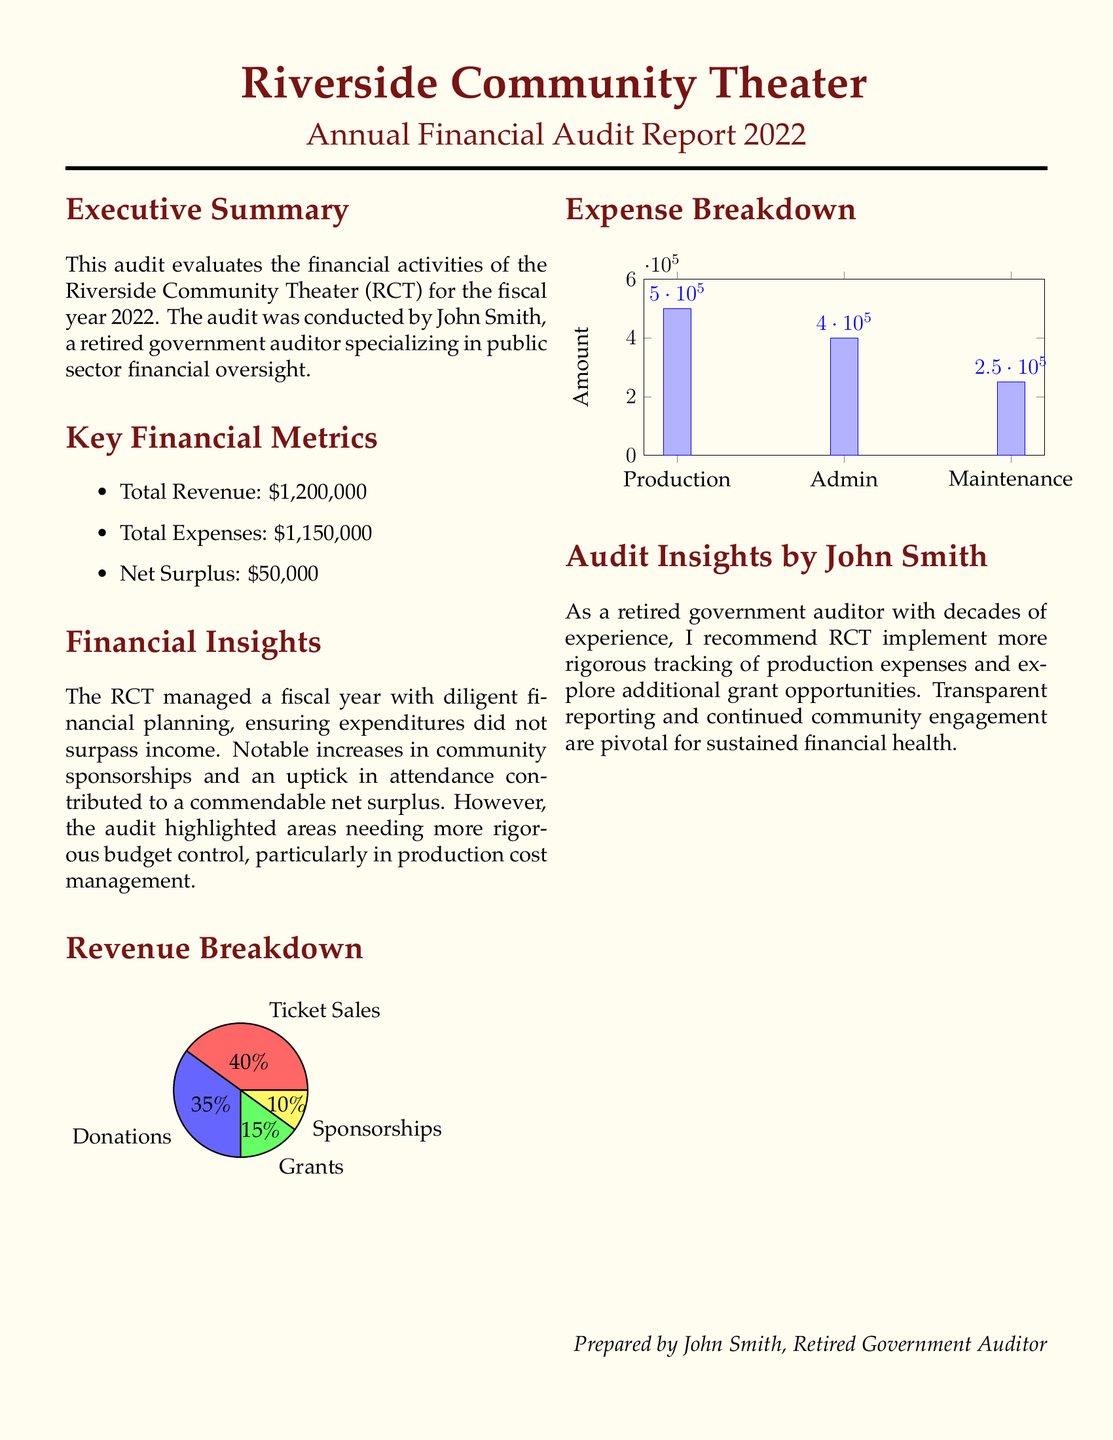What is the total revenue? The total revenue is stated in the document as $1,200,000.
Answer: $1,200,000 What is the net surplus for the year? The net surplus is calculated as total revenue minus total expenses, which is $50,000.
Answer: $50,000 Who conducted the audit? The audit was conducted by John Smith, mentioned in the executive summary.
Answer: John Smith What percentage of revenue came from ticket sales? The pie chart indicates that 40% of revenue was derived from ticket sales.
Answer: 40% What was the total expense amount? The total expenses reported in the document are $1,150,000.
Answer: $1,150,000 Which category had the highest expense? According to the expense breakdown, the category with the highest expense is Production.
Answer: Production What was the total amount allocated for maintenance? The expense breakdown specifies that the amount for maintenance is $250,000.
Answer: $250,000 What recommendation does John Smith provide regarding expenses? John Smith recommends implementing more rigorous tracking of production expenses.
Answer: Tracking production expenses What is the primary source of revenue after ticket sales? The primary source of revenue after ticket sales is donations, as indicated in the revenue breakdown.
Answer: Donations What should RCT explore according to the audit insights? The audit insights recommend exploring additional grant opportunities.
Answer: Additional grant opportunities 